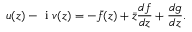<formula> <loc_0><loc_0><loc_500><loc_500>u ( z ) - i v ( z ) = - \bar { f } ( z ) + \bar { z } \frac { d f } { d z } + \frac { d g } { d z } .</formula> 